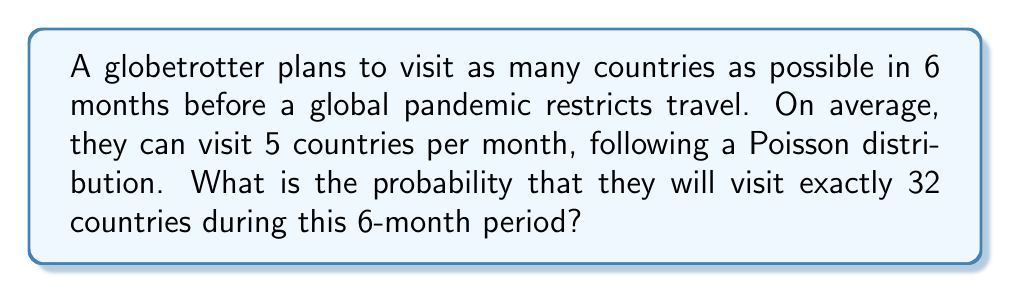Teach me how to tackle this problem. To solve this problem, we'll use the Poisson distribution formula:

$$P(X = k) = \frac{e^{-\lambda} \lambda^k}{k!}$$

Where:
$\lambda$ = average number of events in the given time period
$k$ = specific number of events we're calculating the probability for
$e$ = Euler's number (approximately 2.71828)

Step 1: Calculate $\lambda$ for the 6-month period
$\lambda = 5 \text{ countries/month} \times 6 \text{ months} = 30$

Step 2: Use the Poisson distribution formula with $k = 32$ and $\lambda = 30$

$$P(X = 32) = \frac{e^{-30} 30^{32}}{32!}$$

Step 3: Calculate using a scientific calculator or computer

$$P(X = 32) \approx 0.0730$$

Step 4: Convert to a percentage
$0.0730 \times 100\% = 7.30\%$

Therefore, the probability of visiting exactly 32 countries in 6 months is approximately 7.30%.
Answer: $7.30\%$ 